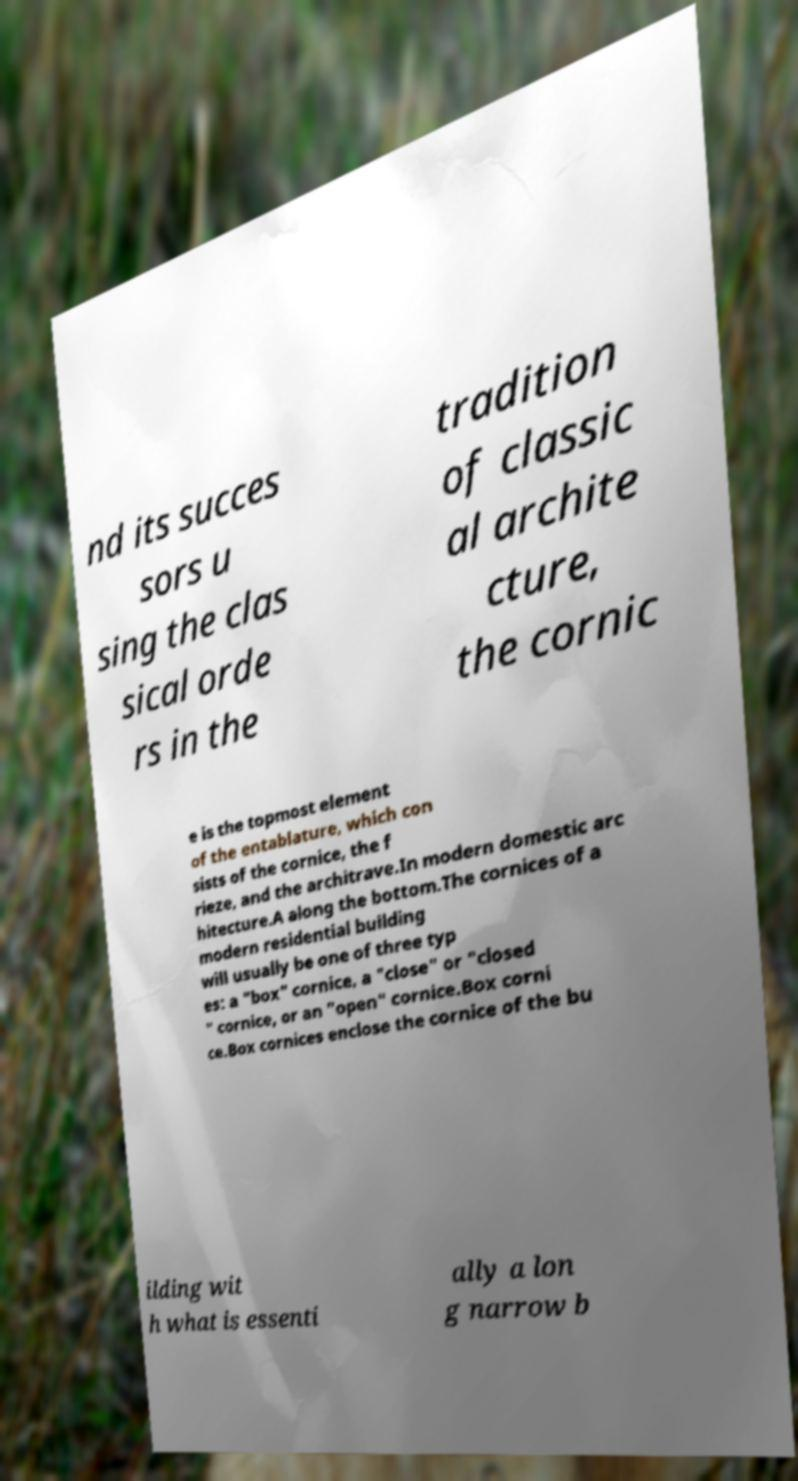Could you assist in decoding the text presented in this image and type it out clearly? nd its succes sors u sing the clas sical orde rs in the tradition of classic al archite cture, the cornic e is the topmost element of the entablature, which con sists of the cornice, the f rieze, and the architrave.In modern domestic arc hitecture.A along the bottom.The cornices of a modern residential building will usually be one of three typ es: a "box" cornice, a "close" or "closed " cornice, or an "open" cornice.Box corni ce.Box cornices enclose the cornice of the bu ilding wit h what is essenti ally a lon g narrow b 